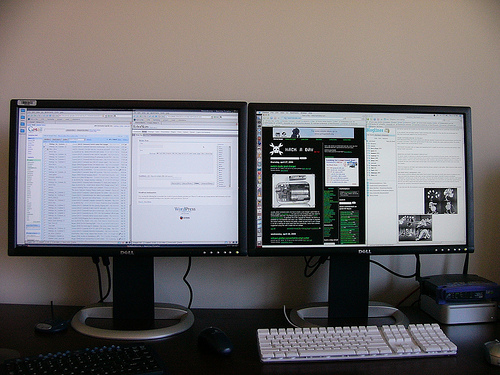<image>
Is there a monitor one to the left of the monitor two? Yes. From this viewpoint, the monitor one is positioned to the left side relative to the monitor two. 